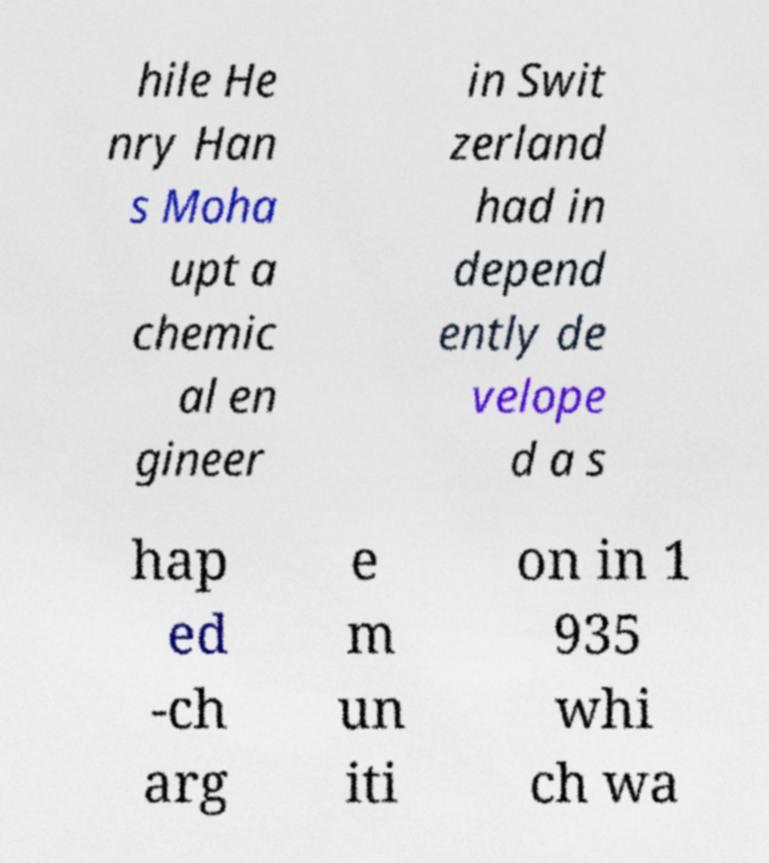Can you read and provide the text displayed in the image?This photo seems to have some interesting text. Can you extract and type it out for me? hile He nry Han s Moha upt a chemic al en gineer in Swit zerland had in depend ently de velope d a s hap ed -ch arg e m un iti on in 1 935 whi ch wa 